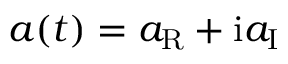Convert formula to latex. <formula><loc_0><loc_0><loc_500><loc_500>a ( t ) = a _ { R } + i a _ { I }</formula> 